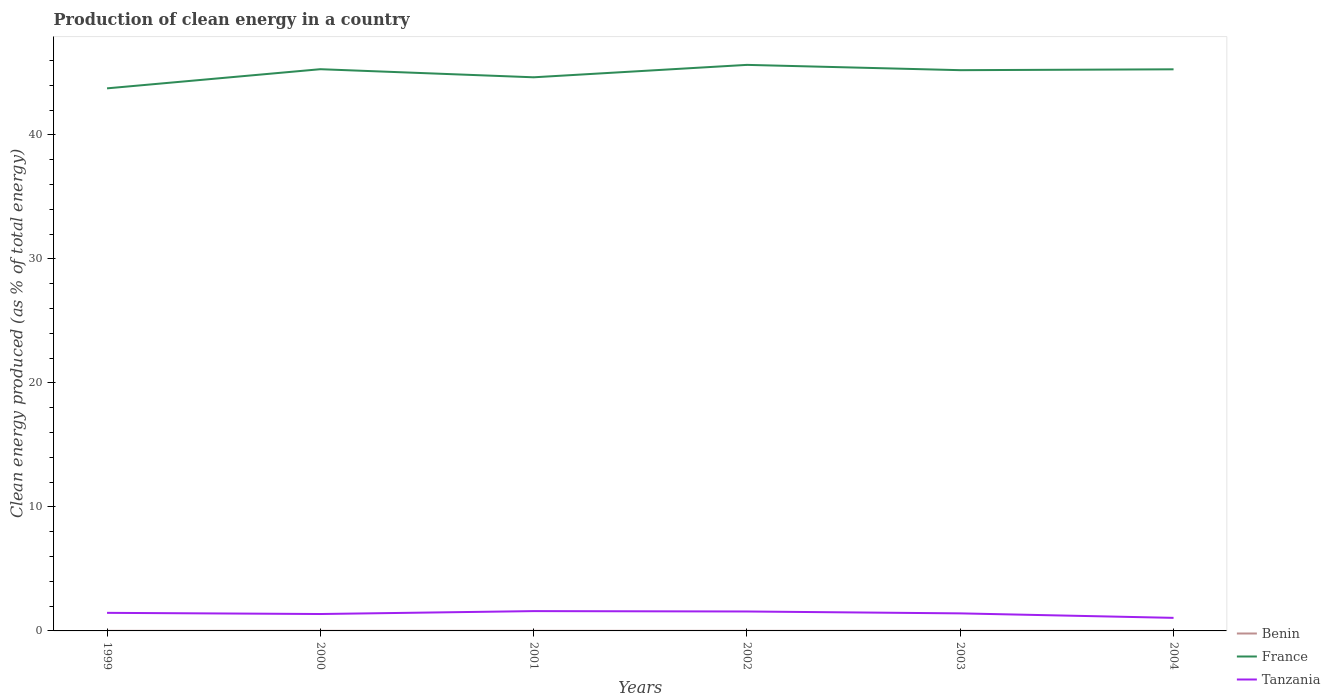How many different coloured lines are there?
Offer a terse response. 3. Does the line corresponding to France intersect with the line corresponding to Benin?
Keep it short and to the point. No. Across all years, what is the maximum percentage of clean energy produced in Benin?
Ensure brevity in your answer.  0. In which year was the percentage of clean energy produced in France maximum?
Ensure brevity in your answer.  1999. What is the total percentage of clean energy produced in France in the graph?
Provide a short and direct response. -1.89. What is the difference between the highest and the second highest percentage of clean energy produced in Tanzania?
Ensure brevity in your answer.  0.54. What is the difference between the highest and the lowest percentage of clean energy produced in France?
Your answer should be compact. 4. What is the difference between two consecutive major ticks on the Y-axis?
Provide a succinct answer. 10. How many legend labels are there?
Make the answer very short. 3. How are the legend labels stacked?
Offer a terse response. Vertical. What is the title of the graph?
Give a very brief answer. Production of clean energy in a country. What is the label or title of the Y-axis?
Your response must be concise. Clean energy produced (as % of total energy). What is the Clean energy produced (as % of total energy) of Benin in 1999?
Give a very brief answer. 0.01. What is the Clean energy produced (as % of total energy) of France in 1999?
Your answer should be very brief. 43.76. What is the Clean energy produced (as % of total energy) of Tanzania in 1999?
Provide a succinct answer. 1.46. What is the Clean energy produced (as % of total energy) of Benin in 2000?
Keep it short and to the point. 0.01. What is the Clean energy produced (as % of total energy) in France in 2000?
Your answer should be compact. 45.31. What is the Clean energy produced (as % of total energy) in Tanzania in 2000?
Provide a short and direct response. 1.36. What is the Clean energy produced (as % of total energy) of Benin in 2001?
Offer a very short reply. 0.01. What is the Clean energy produced (as % of total energy) in France in 2001?
Provide a short and direct response. 44.65. What is the Clean energy produced (as % of total energy) in Tanzania in 2001?
Provide a short and direct response. 1.6. What is the Clean energy produced (as % of total energy) of Benin in 2002?
Your response must be concise. 0.01. What is the Clean energy produced (as % of total energy) of France in 2002?
Make the answer very short. 45.66. What is the Clean energy produced (as % of total energy) in Tanzania in 2002?
Offer a very short reply. 1.57. What is the Clean energy produced (as % of total energy) of Benin in 2003?
Your answer should be compact. 0.01. What is the Clean energy produced (as % of total energy) of France in 2003?
Give a very brief answer. 45.23. What is the Clean energy produced (as % of total energy) in Tanzania in 2003?
Give a very brief answer. 1.42. What is the Clean energy produced (as % of total energy) in Benin in 2004?
Give a very brief answer. 0. What is the Clean energy produced (as % of total energy) in France in 2004?
Provide a short and direct response. 45.3. What is the Clean energy produced (as % of total energy) in Tanzania in 2004?
Your response must be concise. 1.05. Across all years, what is the maximum Clean energy produced (as % of total energy) in Benin?
Your answer should be compact. 0.01. Across all years, what is the maximum Clean energy produced (as % of total energy) in France?
Provide a short and direct response. 45.66. Across all years, what is the maximum Clean energy produced (as % of total energy) in Tanzania?
Make the answer very short. 1.6. Across all years, what is the minimum Clean energy produced (as % of total energy) in Benin?
Provide a short and direct response. 0. Across all years, what is the minimum Clean energy produced (as % of total energy) in France?
Your answer should be very brief. 43.76. Across all years, what is the minimum Clean energy produced (as % of total energy) of Tanzania?
Make the answer very short. 1.05. What is the total Clean energy produced (as % of total energy) of Benin in the graph?
Offer a very short reply. 0.04. What is the total Clean energy produced (as % of total energy) in France in the graph?
Offer a terse response. 269.9. What is the total Clean energy produced (as % of total energy) in Tanzania in the graph?
Provide a short and direct response. 8.46. What is the difference between the Clean energy produced (as % of total energy) in Benin in 1999 and that in 2000?
Offer a very short reply. -0. What is the difference between the Clean energy produced (as % of total energy) of France in 1999 and that in 2000?
Give a very brief answer. -1.54. What is the difference between the Clean energy produced (as % of total energy) in Tanzania in 1999 and that in 2000?
Keep it short and to the point. 0.09. What is the difference between the Clean energy produced (as % of total energy) in Benin in 1999 and that in 2001?
Make the answer very short. -0. What is the difference between the Clean energy produced (as % of total energy) of France in 1999 and that in 2001?
Give a very brief answer. -0.89. What is the difference between the Clean energy produced (as % of total energy) of Tanzania in 1999 and that in 2001?
Ensure brevity in your answer.  -0.14. What is the difference between the Clean energy produced (as % of total energy) of Benin in 1999 and that in 2002?
Your answer should be very brief. -0. What is the difference between the Clean energy produced (as % of total energy) of France in 1999 and that in 2002?
Your answer should be very brief. -1.89. What is the difference between the Clean energy produced (as % of total energy) in Tanzania in 1999 and that in 2002?
Keep it short and to the point. -0.11. What is the difference between the Clean energy produced (as % of total energy) of Benin in 1999 and that in 2003?
Make the answer very short. 0. What is the difference between the Clean energy produced (as % of total energy) of France in 1999 and that in 2003?
Ensure brevity in your answer.  -1.47. What is the difference between the Clean energy produced (as % of total energy) in Tanzania in 1999 and that in 2003?
Give a very brief answer. 0.04. What is the difference between the Clean energy produced (as % of total energy) of Benin in 1999 and that in 2004?
Offer a terse response. 0. What is the difference between the Clean energy produced (as % of total energy) in France in 1999 and that in 2004?
Your response must be concise. -1.54. What is the difference between the Clean energy produced (as % of total energy) of Tanzania in 1999 and that in 2004?
Provide a short and direct response. 0.4. What is the difference between the Clean energy produced (as % of total energy) in France in 2000 and that in 2001?
Your answer should be very brief. 0.65. What is the difference between the Clean energy produced (as % of total energy) in Tanzania in 2000 and that in 2001?
Offer a very short reply. -0.23. What is the difference between the Clean energy produced (as % of total energy) of Benin in 2000 and that in 2002?
Offer a very short reply. 0. What is the difference between the Clean energy produced (as % of total energy) of France in 2000 and that in 2002?
Provide a succinct answer. -0.35. What is the difference between the Clean energy produced (as % of total energy) in Tanzania in 2000 and that in 2002?
Your answer should be very brief. -0.2. What is the difference between the Clean energy produced (as % of total energy) of Benin in 2000 and that in 2003?
Offer a terse response. 0. What is the difference between the Clean energy produced (as % of total energy) of France in 2000 and that in 2003?
Keep it short and to the point. 0.08. What is the difference between the Clean energy produced (as % of total energy) of Tanzania in 2000 and that in 2003?
Your answer should be very brief. -0.05. What is the difference between the Clean energy produced (as % of total energy) of Benin in 2000 and that in 2004?
Offer a terse response. 0.01. What is the difference between the Clean energy produced (as % of total energy) of France in 2000 and that in 2004?
Keep it short and to the point. 0.01. What is the difference between the Clean energy produced (as % of total energy) in Tanzania in 2000 and that in 2004?
Your answer should be very brief. 0.31. What is the difference between the Clean energy produced (as % of total energy) of Benin in 2001 and that in 2002?
Ensure brevity in your answer.  0. What is the difference between the Clean energy produced (as % of total energy) in France in 2001 and that in 2002?
Ensure brevity in your answer.  -1. What is the difference between the Clean energy produced (as % of total energy) of Tanzania in 2001 and that in 2002?
Your response must be concise. 0.03. What is the difference between the Clean energy produced (as % of total energy) of Benin in 2001 and that in 2003?
Your answer should be compact. 0. What is the difference between the Clean energy produced (as % of total energy) in France in 2001 and that in 2003?
Ensure brevity in your answer.  -0.57. What is the difference between the Clean energy produced (as % of total energy) in Tanzania in 2001 and that in 2003?
Provide a succinct answer. 0.18. What is the difference between the Clean energy produced (as % of total energy) in Benin in 2001 and that in 2004?
Offer a very short reply. 0. What is the difference between the Clean energy produced (as % of total energy) of France in 2001 and that in 2004?
Make the answer very short. -0.64. What is the difference between the Clean energy produced (as % of total energy) of Tanzania in 2001 and that in 2004?
Your response must be concise. 0.54. What is the difference between the Clean energy produced (as % of total energy) in France in 2002 and that in 2003?
Offer a very short reply. 0.43. What is the difference between the Clean energy produced (as % of total energy) in Tanzania in 2002 and that in 2003?
Ensure brevity in your answer.  0.15. What is the difference between the Clean energy produced (as % of total energy) of Benin in 2002 and that in 2004?
Your answer should be very brief. 0. What is the difference between the Clean energy produced (as % of total energy) of France in 2002 and that in 2004?
Keep it short and to the point. 0.36. What is the difference between the Clean energy produced (as % of total energy) of Tanzania in 2002 and that in 2004?
Offer a very short reply. 0.51. What is the difference between the Clean energy produced (as % of total energy) of Benin in 2003 and that in 2004?
Give a very brief answer. 0. What is the difference between the Clean energy produced (as % of total energy) in France in 2003 and that in 2004?
Provide a short and direct response. -0.07. What is the difference between the Clean energy produced (as % of total energy) in Tanzania in 2003 and that in 2004?
Offer a terse response. 0.36. What is the difference between the Clean energy produced (as % of total energy) of Benin in 1999 and the Clean energy produced (as % of total energy) of France in 2000?
Provide a succinct answer. -45.3. What is the difference between the Clean energy produced (as % of total energy) of Benin in 1999 and the Clean energy produced (as % of total energy) of Tanzania in 2000?
Keep it short and to the point. -1.36. What is the difference between the Clean energy produced (as % of total energy) in France in 1999 and the Clean energy produced (as % of total energy) in Tanzania in 2000?
Offer a very short reply. 42.4. What is the difference between the Clean energy produced (as % of total energy) in Benin in 1999 and the Clean energy produced (as % of total energy) in France in 2001?
Offer a terse response. -44.65. What is the difference between the Clean energy produced (as % of total energy) in Benin in 1999 and the Clean energy produced (as % of total energy) in Tanzania in 2001?
Provide a succinct answer. -1.59. What is the difference between the Clean energy produced (as % of total energy) of France in 1999 and the Clean energy produced (as % of total energy) of Tanzania in 2001?
Your answer should be compact. 42.16. What is the difference between the Clean energy produced (as % of total energy) in Benin in 1999 and the Clean energy produced (as % of total energy) in France in 2002?
Your response must be concise. -45.65. What is the difference between the Clean energy produced (as % of total energy) in Benin in 1999 and the Clean energy produced (as % of total energy) in Tanzania in 2002?
Your answer should be very brief. -1.56. What is the difference between the Clean energy produced (as % of total energy) of France in 1999 and the Clean energy produced (as % of total energy) of Tanzania in 2002?
Give a very brief answer. 42.19. What is the difference between the Clean energy produced (as % of total energy) in Benin in 1999 and the Clean energy produced (as % of total energy) in France in 2003?
Make the answer very short. -45.22. What is the difference between the Clean energy produced (as % of total energy) in Benin in 1999 and the Clean energy produced (as % of total energy) in Tanzania in 2003?
Keep it short and to the point. -1.41. What is the difference between the Clean energy produced (as % of total energy) in France in 1999 and the Clean energy produced (as % of total energy) in Tanzania in 2003?
Your answer should be very brief. 42.35. What is the difference between the Clean energy produced (as % of total energy) in Benin in 1999 and the Clean energy produced (as % of total energy) in France in 2004?
Give a very brief answer. -45.29. What is the difference between the Clean energy produced (as % of total energy) of Benin in 1999 and the Clean energy produced (as % of total energy) of Tanzania in 2004?
Make the answer very short. -1.05. What is the difference between the Clean energy produced (as % of total energy) of France in 1999 and the Clean energy produced (as % of total energy) of Tanzania in 2004?
Offer a terse response. 42.71. What is the difference between the Clean energy produced (as % of total energy) of Benin in 2000 and the Clean energy produced (as % of total energy) of France in 2001?
Make the answer very short. -44.64. What is the difference between the Clean energy produced (as % of total energy) in Benin in 2000 and the Clean energy produced (as % of total energy) in Tanzania in 2001?
Offer a terse response. -1.59. What is the difference between the Clean energy produced (as % of total energy) in France in 2000 and the Clean energy produced (as % of total energy) in Tanzania in 2001?
Provide a short and direct response. 43.71. What is the difference between the Clean energy produced (as % of total energy) in Benin in 2000 and the Clean energy produced (as % of total energy) in France in 2002?
Offer a terse response. -45.65. What is the difference between the Clean energy produced (as % of total energy) of Benin in 2000 and the Clean energy produced (as % of total energy) of Tanzania in 2002?
Your answer should be very brief. -1.56. What is the difference between the Clean energy produced (as % of total energy) in France in 2000 and the Clean energy produced (as % of total energy) in Tanzania in 2002?
Ensure brevity in your answer.  43.74. What is the difference between the Clean energy produced (as % of total energy) in Benin in 2000 and the Clean energy produced (as % of total energy) in France in 2003?
Ensure brevity in your answer.  -45.22. What is the difference between the Clean energy produced (as % of total energy) of Benin in 2000 and the Clean energy produced (as % of total energy) of Tanzania in 2003?
Your response must be concise. -1.41. What is the difference between the Clean energy produced (as % of total energy) in France in 2000 and the Clean energy produced (as % of total energy) in Tanzania in 2003?
Offer a very short reply. 43.89. What is the difference between the Clean energy produced (as % of total energy) of Benin in 2000 and the Clean energy produced (as % of total energy) of France in 2004?
Keep it short and to the point. -45.29. What is the difference between the Clean energy produced (as % of total energy) of Benin in 2000 and the Clean energy produced (as % of total energy) of Tanzania in 2004?
Provide a short and direct response. -1.05. What is the difference between the Clean energy produced (as % of total energy) of France in 2000 and the Clean energy produced (as % of total energy) of Tanzania in 2004?
Your answer should be compact. 44.25. What is the difference between the Clean energy produced (as % of total energy) in Benin in 2001 and the Clean energy produced (as % of total energy) in France in 2002?
Make the answer very short. -45.65. What is the difference between the Clean energy produced (as % of total energy) of Benin in 2001 and the Clean energy produced (as % of total energy) of Tanzania in 2002?
Give a very brief answer. -1.56. What is the difference between the Clean energy produced (as % of total energy) in France in 2001 and the Clean energy produced (as % of total energy) in Tanzania in 2002?
Provide a short and direct response. 43.09. What is the difference between the Clean energy produced (as % of total energy) in Benin in 2001 and the Clean energy produced (as % of total energy) in France in 2003?
Offer a terse response. -45.22. What is the difference between the Clean energy produced (as % of total energy) of Benin in 2001 and the Clean energy produced (as % of total energy) of Tanzania in 2003?
Offer a terse response. -1.41. What is the difference between the Clean energy produced (as % of total energy) of France in 2001 and the Clean energy produced (as % of total energy) of Tanzania in 2003?
Your answer should be very brief. 43.24. What is the difference between the Clean energy produced (as % of total energy) in Benin in 2001 and the Clean energy produced (as % of total energy) in France in 2004?
Give a very brief answer. -45.29. What is the difference between the Clean energy produced (as % of total energy) in Benin in 2001 and the Clean energy produced (as % of total energy) in Tanzania in 2004?
Give a very brief answer. -1.05. What is the difference between the Clean energy produced (as % of total energy) of France in 2001 and the Clean energy produced (as % of total energy) of Tanzania in 2004?
Provide a succinct answer. 43.6. What is the difference between the Clean energy produced (as % of total energy) of Benin in 2002 and the Clean energy produced (as % of total energy) of France in 2003?
Your answer should be very brief. -45.22. What is the difference between the Clean energy produced (as % of total energy) in Benin in 2002 and the Clean energy produced (as % of total energy) in Tanzania in 2003?
Provide a succinct answer. -1.41. What is the difference between the Clean energy produced (as % of total energy) in France in 2002 and the Clean energy produced (as % of total energy) in Tanzania in 2003?
Keep it short and to the point. 44.24. What is the difference between the Clean energy produced (as % of total energy) in Benin in 2002 and the Clean energy produced (as % of total energy) in France in 2004?
Provide a short and direct response. -45.29. What is the difference between the Clean energy produced (as % of total energy) in Benin in 2002 and the Clean energy produced (as % of total energy) in Tanzania in 2004?
Your answer should be compact. -1.05. What is the difference between the Clean energy produced (as % of total energy) of France in 2002 and the Clean energy produced (as % of total energy) of Tanzania in 2004?
Provide a short and direct response. 44.6. What is the difference between the Clean energy produced (as % of total energy) of Benin in 2003 and the Clean energy produced (as % of total energy) of France in 2004?
Make the answer very short. -45.29. What is the difference between the Clean energy produced (as % of total energy) in Benin in 2003 and the Clean energy produced (as % of total energy) in Tanzania in 2004?
Provide a short and direct response. -1.05. What is the difference between the Clean energy produced (as % of total energy) in France in 2003 and the Clean energy produced (as % of total energy) in Tanzania in 2004?
Make the answer very short. 44.17. What is the average Clean energy produced (as % of total energy) in Benin per year?
Provide a succinct answer. 0.01. What is the average Clean energy produced (as % of total energy) in France per year?
Provide a short and direct response. 44.98. What is the average Clean energy produced (as % of total energy) in Tanzania per year?
Offer a terse response. 1.41. In the year 1999, what is the difference between the Clean energy produced (as % of total energy) in Benin and Clean energy produced (as % of total energy) in France?
Keep it short and to the point. -43.75. In the year 1999, what is the difference between the Clean energy produced (as % of total energy) in Benin and Clean energy produced (as % of total energy) in Tanzania?
Ensure brevity in your answer.  -1.45. In the year 1999, what is the difference between the Clean energy produced (as % of total energy) of France and Clean energy produced (as % of total energy) of Tanzania?
Give a very brief answer. 42.3. In the year 2000, what is the difference between the Clean energy produced (as % of total energy) of Benin and Clean energy produced (as % of total energy) of France?
Your answer should be compact. -45.3. In the year 2000, what is the difference between the Clean energy produced (as % of total energy) of Benin and Clean energy produced (as % of total energy) of Tanzania?
Your answer should be very brief. -1.36. In the year 2000, what is the difference between the Clean energy produced (as % of total energy) in France and Clean energy produced (as % of total energy) in Tanzania?
Your answer should be compact. 43.94. In the year 2001, what is the difference between the Clean energy produced (as % of total energy) of Benin and Clean energy produced (as % of total energy) of France?
Provide a succinct answer. -44.65. In the year 2001, what is the difference between the Clean energy produced (as % of total energy) in Benin and Clean energy produced (as % of total energy) in Tanzania?
Give a very brief answer. -1.59. In the year 2001, what is the difference between the Clean energy produced (as % of total energy) in France and Clean energy produced (as % of total energy) in Tanzania?
Your answer should be very brief. 43.06. In the year 2002, what is the difference between the Clean energy produced (as % of total energy) of Benin and Clean energy produced (as % of total energy) of France?
Make the answer very short. -45.65. In the year 2002, what is the difference between the Clean energy produced (as % of total energy) in Benin and Clean energy produced (as % of total energy) in Tanzania?
Provide a succinct answer. -1.56. In the year 2002, what is the difference between the Clean energy produced (as % of total energy) of France and Clean energy produced (as % of total energy) of Tanzania?
Ensure brevity in your answer.  44.09. In the year 2003, what is the difference between the Clean energy produced (as % of total energy) of Benin and Clean energy produced (as % of total energy) of France?
Your answer should be compact. -45.22. In the year 2003, what is the difference between the Clean energy produced (as % of total energy) of Benin and Clean energy produced (as % of total energy) of Tanzania?
Offer a very short reply. -1.41. In the year 2003, what is the difference between the Clean energy produced (as % of total energy) of France and Clean energy produced (as % of total energy) of Tanzania?
Keep it short and to the point. 43.81. In the year 2004, what is the difference between the Clean energy produced (as % of total energy) in Benin and Clean energy produced (as % of total energy) in France?
Make the answer very short. -45.29. In the year 2004, what is the difference between the Clean energy produced (as % of total energy) in Benin and Clean energy produced (as % of total energy) in Tanzania?
Give a very brief answer. -1.05. In the year 2004, what is the difference between the Clean energy produced (as % of total energy) in France and Clean energy produced (as % of total energy) in Tanzania?
Your response must be concise. 44.24. What is the ratio of the Clean energy produced (as % of total energy) of Benin in 1999 to that in 2000?
Your answer should be compact. 0.86. What is the ratio of the Clean energy produced (as % of total energy) of France in 1999 to that in 2000?
Your answer should be compact. 0.97. What is the ratio of the Clean energy produced (as % of total energy) of Tanzania in 1999 to that in 2000?
Make the answer very short. 1.07. What is the ratio of the Clean energy produced (as % of total energy) of Benin in 1999 to that in 2001?
Ensure brevity in your answer.  0.92. What is the ratio of the Clean energy produced (as % of total energy) in Tanzania in 1999 to that in 2001?
Make the answer very short. 0.91. What is the ratio of the Clean energy produced (as % of total energy) of Benin in 1999 to that in 2002?
Provide a short and direct response. 0.98. What is the ratio of the Clean energy produced (as % of total energy) in France in 1999 to that in 2002?
Your answer should be compact. 0.96. What is the ratio of the Clean energy produced (as % of total energy) in Tanzania in 1999 to that in 2002?
Give a very brief answer. 0.93. What is the ratio of the Clean energy produced (as % of total energy) in Benin in 1999 to that in 2003?
Give a very brief answer. 1.04. What is the ratio of the Clean energy produced (as % of total energy) of France in 1999 to that in 2003?
Provide a succinct answer. 0.97. What is the ratio of the Clean energy produced (as % of total energy) in Tanzania in 1999 to that in 2003?
Offer a terse response. 1.03. What is the ratio of the Clean energy produced (as % of total energy) in Benin in 1999 to that in 2004?
Your answer should be very brief. 2.17. What is the ratio of the Clean energy produced (as % of total energy) in France in 1999 to that in 2004?
Keep it short and to the point. 0.97. What is the ratio of the Clean energy produced (as % of total energy) in Tanzania in 1999 to that in 2004?
Your answer should be very brief. 1.38. What is the ratio of the Clean energy produced (as % of total energy) of Benin in 2000 to that in 2001?
Your answer should be compact. 1.06. What is the ratio of the Clean energy produced (as % of total energy) of France in 2000 to that in 2001?
Provide a short and direct response. 1.01. What is the ratio of the Clean energy produced (as % of total energy) in Tanzania in 2000 to that in 2001?
Provide a succinct answer. 0.85. What is the ratio of the Clean energy produced (as % of total energy) of Benin in 2000 to that in 2002?
Your answer should be compact. 1.14. What is the ratio of the Clean energy produced (as % of total energy) of Tanzania in 2000 to that in 2002?
Keep it short and to the point. 0.87. What is the ratio of the Clean energy produced (as % of total energy) in Benin in 2000 to that in 2003?
Keep it short and to the point. 1.2. What is the ratio of the Clean energy produced (as % of total energy) in France in 2000 to that in 2003?
Your answer should be compact. 1. What is the ratio of the Clean energy produced (as % of total energy) in Tanzania in 2000 to that in 2003?
Your response must be concise. 0.96. What is the ratio of the Clean energy produced (as % of total energy) of Benin in 2000 to that in 2004?
Keep it short and to the point. 2.51. What is the ratio of the Clean energy produced (as % of total energy) of France in 2000 to that in 2004?
Provide a short and direct response. 1. What is the ratio of the Clean energy produced (as % of total energy) in Tanzania in 2000 to that in 2004?
Your response must be concise. 1.29. What is the ratio of the Clean energy produced (as % of total energy) in Benin in 2001 to that in 2002?
Provide a short and direct response. 1.07. What is the ratio of the Clean energy produced (as % of total energy) in France in 2001 to that in 2002?
Make the answer very short. 0.98. What is the ratio of the Clean energy produced (as % of total energy) of Benin in 2001 to that in 2003?
Ensure brevity in your answer.  1.13. What is the ratio of the Clean energy produced (as % of total energy) in France in 2001 to that in 2003?
Your answer should be very brief. 0.99. What is the ratio of the Clean energy produced (as % of total energy) in Tanzania in 2001 to that in 2003?
Keep it short and to the point. 1.13. What is the ratio of the Clean energy produced (as % of total energy) in Benin in 2001 to that in 2004?
Make the answer very short. 2.36. What is the ratio of the Clean energy produced (as % of total energy) of France in 2001 to that in 2004?
Your answer should be very brief. 0.99. What is the ratio of the Clean energy produced (as % of total energy) in Tanzania in 2001 to that in 2004?
Your response must be concise. 1.52. What is the ratio of the Clean energy produced (as % of total energy) in Benin in 2002 to that in 2003?
Give a very brief answer. 1.05. What is the ratio of the Clean energy produced (as % of total energy) of France in 2002 to that in 2003?
Offer a terse response. 1.01. What is the ratio of the Clean energy produced (as % of total energy) of Tanzania in 2002 to that in 2003?
Your response must be concise. 1.11. What is the ratio of the Clean energy produced (as % of total energy) of Benin in 2002 to that in 2004?
Your answer should be compact. 2.2. What is the ratio of the Clean energy produced (as % of total energy) of France in 2002 to that in 2004?
Ensure brevity in your answer.  1.01. What is the ratio of the Clean energy produced (as % of total energy) in Tanzania in 2002 to that in 2004?
Give a very brief answer. 1.49. What is the ratio of the Clean energy produced (as % of total energy) in Benin in 2003 to that in 2004?
Provide a succinct answer. 2.09. What is the ratio of the Clean energy produced (as % of total energy) in Tanzania in 2003 to that in 2004?
Keep it short and to the point. 1.34. What is the difference between the highest and the second highest Clean energy produced (as % of total energy) of Benin?
Give a very brief answer. 0. What is the difference between the highest and the second highest Clean energy produced (as % of total energy) of France?
Your answer should be very brief. 0.35. What is the difference between the highest and the second highest Clean energy produced (as % of total energy) in Tanzania?
Keep it short and to the point. 0.03. What is the difference between the highest and the lowest Clean energy produced (as % of total energy) of Benin?
Provide a succinct answer. 0.01. What is the difference between the highest and the lowest Clean energy produced (as % of total energy) in France?
Your response must be concise. 1.89. What is the difference between the highest and the lowest Clean energy produced (as % of total energy) of Tanzania?
Your answer should be compact. 0.54. 